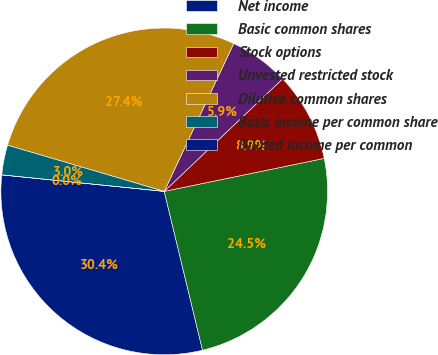Convert chart to OTSL. <chart><loc_0><loc_0><loc_500><loc_500><pie_chart><fcel>Net income<fcel>Basic common shares<fcel>Stock options<fcel>Unvested restricted stock<fcel>Dilutive common shares<fcel>Basic income per common share<fcel>Diluted income per common<nl><fcel>30.38%<fcel>24.47%<fcel>8.86%<fcel>5.91%<fcel>27.43%<fcel>2.95%<fcel>0.0%<nl></chart> 